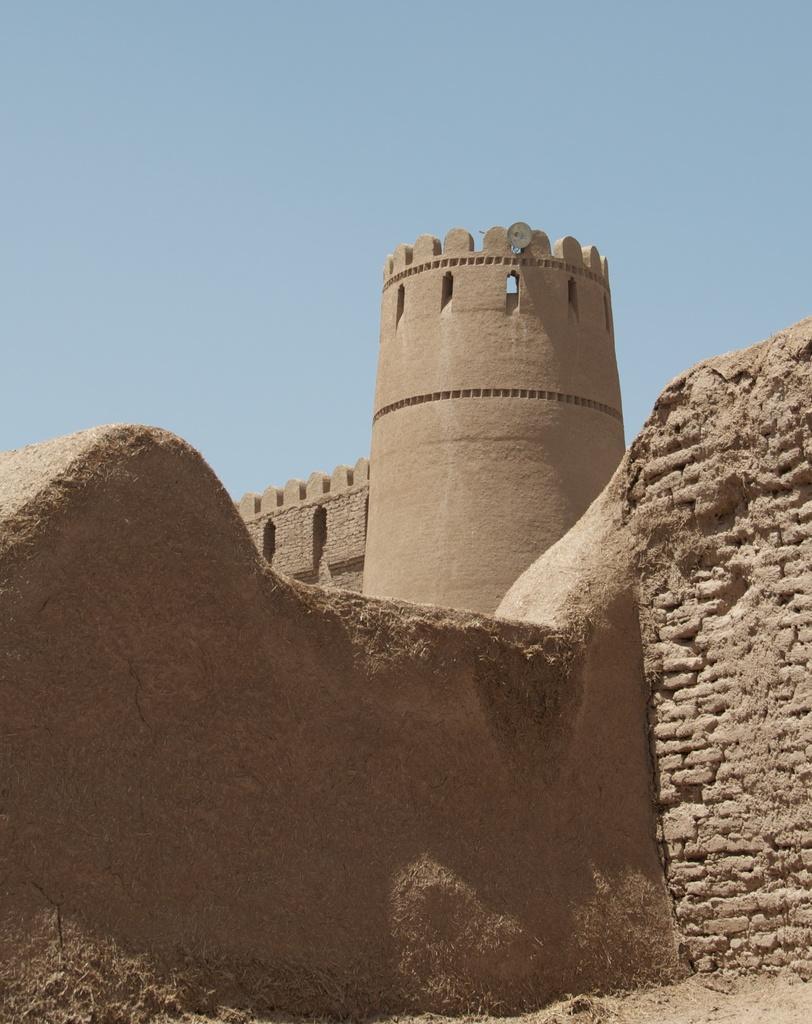How would you summarize this image in a sentence or two? In this image I see the fort which is of brown in color and I see the wall over here which is of soil and stones and in the background I see the blue sky. 